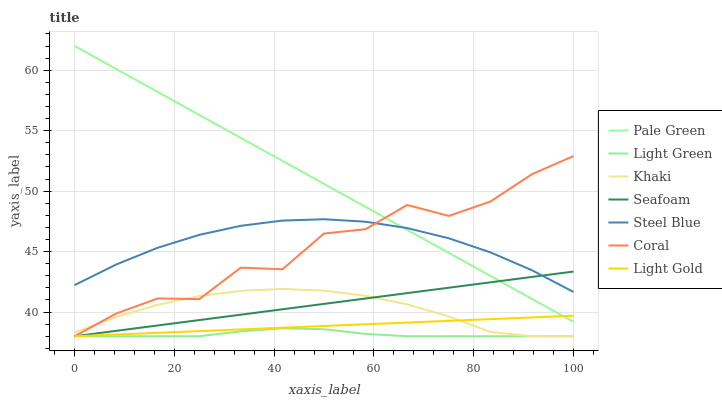Does Light Green have the minimum area under the curve?
Answer yes or no. Yes. Does Pale Green have the maximum area under the curve?
Answer yes or no. Yes. Does Coral have the minimum area under the curve?
Answer yes or no. No. Does Coral have the maximum area under the curve?
Answer yes or no. No. Is Light Gold the smoothest?
Answer yes or no. Yes. Is Coral the roughest?
Answer yes or no. Yes. Is Steel Blue the smoothest?
Answer yes or no. No. Is Steel Blue the roughest?
Answer yes or no. No. Does Khaki have the lowest value?
Answer yes or no. Yes. Does Steel Blue have the lowest value?
Answer yes or no. No. Does Pale Green have the highest value?
Answer yes or no. Yes. Does Coral have the highest value?
Answer yes or no. No. Is Khaki less than Pale Green?
Answer yes or no. Yes. Is Steel Blue greater than Light Gold?
Answer yes or no. Yes. Does Seafoam intersect Coral?
Answer yes or no. Yes. Is Seafoam less than Coral?
Answer yes or no. No. Is Seafoam greater than Coral?
Answer yes or no. No. Does Khaki intersect Pale Green?
Answer yes or no. No. 